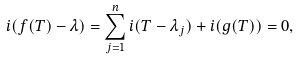Convert formula to latex. <formula><loc_0><loc_0><loc_500><loc_500>i ( f ( T ) - \lambda ) = \sum _ { j = 1 } ^ { n } i ( T - \lambda _ { j } ) + i ( g ( T ) ) = 0 ,</formula> 